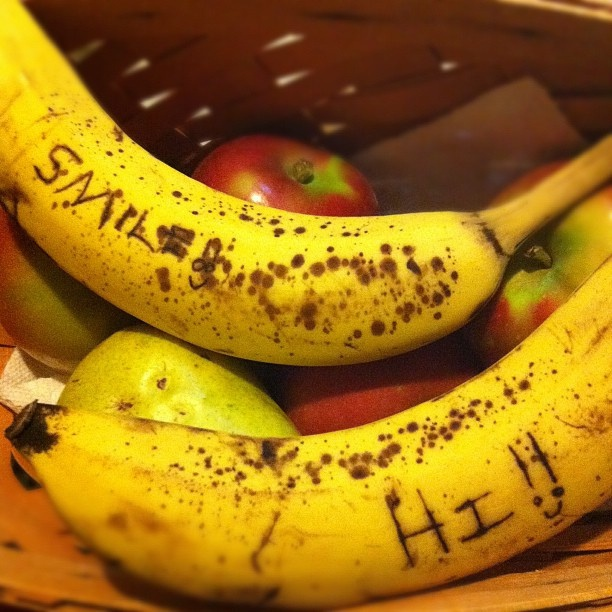Describe the objects in this image and their specific colors. I can see banana in gold, orange, olive, and maroon tones, apple in gold, maroon, olive, and black tones, apple in gold, black, brown, and maroon tones, apple in gold, brown, maroon, and olive tones, and apple in gold, maroon, olive, and black tones in this image. 